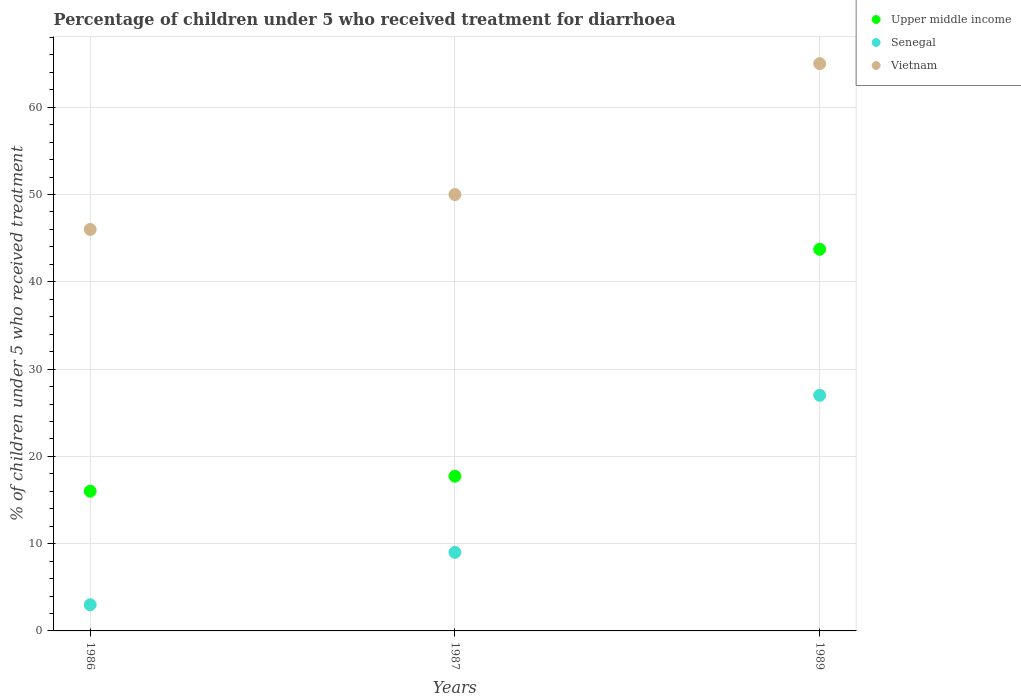Is the number of dotlines equal to the number of legend labels?
Ensure brevity in your answer.  Yes. What is the percentage of children who received treatment for diarrhoea  in Upper middle income in 1986?
Provide a succinct answer. 16.01. Across all years, what is the maximum percentage of children who received treatment for diarrhoea  in Vietnam?
Provide a short and direct response. 65. Across all years, what is the minimum percentage of children who received treatment for diarrhoea  in Upper middle income?
Your answer should be compact. 16.01. What is the difference between the percentage of children who received treatment for diarrhoea  in Upper middle income in 1986 and that in 1987?
Your answer should be compact. -1.72. What is the average percentage of children who received treatment for diarrhoea  in Vietnam per year?
Your answer should be compact. 53.67. In the year 1986, what is the difference between the percentage of children who received treatment for diarrhoea  in Senegal and percentage of children who received treatment for diarrhoea  in Upper middle income?
Your answer should be compact. -13.01. In how many years, is the percentage of children who received treatment for diarrhoea  in Vietnam greater than 12 %?
Your answer should be compact. 3. What is the ratio of the percentage of children who received treatment for diarrhoea  in Vietnam in 1986 to that in 1987?
Your answer should be very brief. 0.92. Is the percentage of children who received treatment for diarrhoea  in Senegal in 1986 less than that in 1987?
Provide a succinct answer. Yes. What is the difference between the highest and the second highest percentage of children who received treatment for diarrhoea  in Vietnam?
Your response must be concise. 15. In how many years, is the percentage of children who received treatment for diarrhoea  in Upper middle income greater than the average percentage of children who received treatment for diarrhoea  in Upper middle income taken over all years?
Your response must be concise. 1. Is the sum of the percentage of children who received treatment for diarrhoea  in Senegal in 1987 and 1989 greater than the maximum percentage of children who received treatment for diarrhoea  in Vietnam across all years?
Your answer should be compact. No. Is it the case that in every year, the sum of the percentage of children who received treatment for diarrhoea  in Upper middle income and percentage of children who received treatment for diarrhoea  in Vietnam  is greater than the percentage of children who received treatment for diarrhoea  in Senegal?
Make the answer very short. Yes. Is the percentage of children who received treatment for diarrhoea  in Upper middle income strictly greater than the percentage of children who received treatment for diarrhoea  in Vietnam over the years?
Offer a very short reply. No. How many dotlines are there?
Your answer should be very brief. 3. How many years are there in the graph?
Your answer should be very brief. 3. Does the graph contain any zero values?
Give a very brief answer. No. Does the graph contain grids?
Provide a short and direct response. Yes. How many legend labels are there?
Your answer should be compact. 3. What is the title of the graph?
Give a very brief answer. Percentage of children under 5 who received treatment for diarrhoea. What is the label or title of the X-axis?
Provide a succinct answer. Years. What is the label or title of the Y-axis?
Give a very brief answer. % of children under 5 who received treatment. What is the % of children under 5 who received treatment of Upper middle income in 1986?
Your answer should be compact. 16.01. What is the % of children under 5 who received treatment in Senegal in 1986?
Provide a succinct answer. 3. What is the % of children under 5 who received treatment of Vietnam in 1986?
Your answer should be very brief. 46. What is the % of children under 5 who received treatment of Upper middle income in 1987?
Your answer should be compact. 17.73. What is the % of children under 5 who received treatment in Senegal in 1987?
Your answer should be compact. 9. What is the % of children under 5 who received treatment of Upper middle income in 1989?
Provide a succinct answer. 43.73. What is the % of children under 5 who received treatment in Senegal in 1989?
Keep it short and to the point. 27. What is the % of children under 5 who received treatment in Vietnam in 1989?
Provide a succinct answer. 65. Across all years, what is the maximum % of children under 5 who received treatment of Upper middle income?
Give a very brief answer. 43.73. Across all years, what is the minimum % of children under 5 who received treatment in Upper middle income?
Make the answer very short. 16.01. Across all years, what is the minimum % of children under 5 who received treatment in Vietnam?
Your answer should be very brief. 46. What is the total % of children under 5 who received treatment in Upper middle income in the graph?
Give a very brief answer. 77.47. What is the total % of children under 5 who received treatment of Vietnam in the graph?
Ensure brevity in your answer.  161. What is the difference between the % of children under 5 who received treatment in Upper middle income in 1986 and that in 1987?
Ensure brevity in your answer.  -1.72. What is the difference between the % of children under 5 who received treatment in Vietnam in 1986 and that in 1987?
Offer a terse response. -4. What is the difference between the % of children under 5 who received treatment of Upper middle income in 1986 and that in 1989?
Give a very brief answer. -27.72. What is the difference between the % of children under 5 who received treatment in Upper middle income in 1987 and that in 1989?
Your answer should be compact. -26. What is the difference between the % of children under 5 who received treatment of Senegal in 1987 and that in 1989?
Your answer should be compact. -18. What is the difference between the % of children under 5 who received treatment in Upper middle income in 1986 and the % of children under 5 who received treatment in Senegal in 1987?
Offer a terse response. 7.01. What is the difference between the % of children under 5 who received treatment of Upper middle income in 1986 and the % of children under 5 who received treatment of Vietnam in 1987?
Offer a very short reply. -33.99. What is the difference between the % of children under 5 who received treatment in Senegal in 1986 and the % of children under 5 who received treatment in Vietnam in 1987?
Your response must be concise. -47. What is the difference between the % of children under 5 who received treatment of Upper middle income in 1986 and the % of children under 5 who received treatment of Senegal in 1989?
Provide a succinct answer. -10.99. What is the difference between the % of children under 5 who received treatment of Upper middle income in 1986 and the % of children under 5 who received treatment of Vietnam in 1989?
Provide a short and direct response. -48.99. What is the difference between the % of children under 5 who received treatment in Senegal in 1986 and the % of children under 5 who received treatment in Vietnam in 1989?
Offer a terse response. -62. What is the difference between the % of children under 5 who received treatment in Upper middle income in 1987 and the % of children under 5 who received treatment in Senegal in 1989?
Your response must be concise. -9.27. What is the difference between the % of children under 5 who received treatment of Upper middle income in 1987 and the % of children under 5 who received treatment of Vietnam in 1989?
Ensure brevity in your answer.  -47.27. What is the difference between the % of children under 5 who received treatment of Senegal in 1987 and the % of children under 5 who received treatment of Vietnam in 1989?
Your answer should be very brief. -56. What is the average % of children under 5 who received treatment of Upper middle income per year?
Make the answer very short. 25.82. What is the average % of children under 5 who received treatment of Senegal per year?
Your answer should be compact. 13. What is the average % of children under 5 who received treatment of Vietnam per year?
Provide a short and direct response. 53.67. In the year 1986, what is the difference between the % of children under 5 who received treatment of Upper middle income and % of children under 5 who received treatment of Senegal?
Your response must be concise. 13.01. In the year 1986, what is the difference between the % of children under 5 who received treatment in Upper middle income and % of children under 5 who received treatment in Vietnam?
Make the answer very short. -29.99. In the year 1986, what is the difference between the % of children under 5 who received treatment in Senegal and % of children under 5 who received treatment in Vietnam?
Your answer should be compact. -43. In the year 1987, what is the difference between the % of children under 5 who received treatment of Upper middle income and % of children under 5 who received treatment of Senegal?
Offer a very short reply. 8.73. In the year 1987, what is the difference between the % of children under 5 who received treatment in Upper middle income and % of children under 5 who received treatment in Vietnam?
Provide a succinct answer. -32.27. In the year 1987, what is the difference between the % of children under 5 who received treatment in Senegal and % of children under 5 who received treatment in Vietnam?
Offer a terse response. -41. In the year 1989, what is the difference between the % of children under 5 who received treatment of Upper middle income and % of children under 5 who received treatment of Senegal?
Your answer should be very brief. 16.73. In the year 1989, what is the difference between the % of children under 5 who received treatment of Upper middle income and % of children under 5 who received treatment of Vietnam?
Provide a succinct answer. -21.27. In the year 1989, what is the difference between the % of children under 5 who received treatment in Senegal and % of children under 5 who received treatment in Vietnam?
Offer a terse response. -38. What is the ratio of the % of children under 5 who received treatment in Upper middle income in 1986 to that in 1987?
Provide a short and direct response. 0.9. What is the ratio of the % of children under 5 who received treatment in Upper middle income in 1986 to that in 1989?
Provide a succinct answer. 0.37. What is the ratio of the % of children under 5 who received treatment of Vietnam in 1986 to that in 1989?
Your answer should be compact. 0.71. What is the ratio of the % of children under 5 who received treatment in Upper middle income in 1987 to that in 1989?
Provide a succinct answer. 0.41. What is the ratio of the % of children under 5 who received treatment of Senegal in 1987 to that in 1989?
Your answer should be compact. 0.33. What is the ratio of the % of children under 5 who received treatment in Vietnam in 1987 to that in 1989?
Provide a short and direct response. 0.77. What is the difference between the highest and the second highest % of children under 5 who received treatment of Upper middle income?
Offer a very short reply. 26. What is the difference between the highest and the lowest % of children under 5 who received treatment of Upper middle income?
Your response must be concise. 27.72. What is the difference between the highest and the lowest % of children under 5 who received treatment in Vietnam?
Offer a very short reply. 19. 